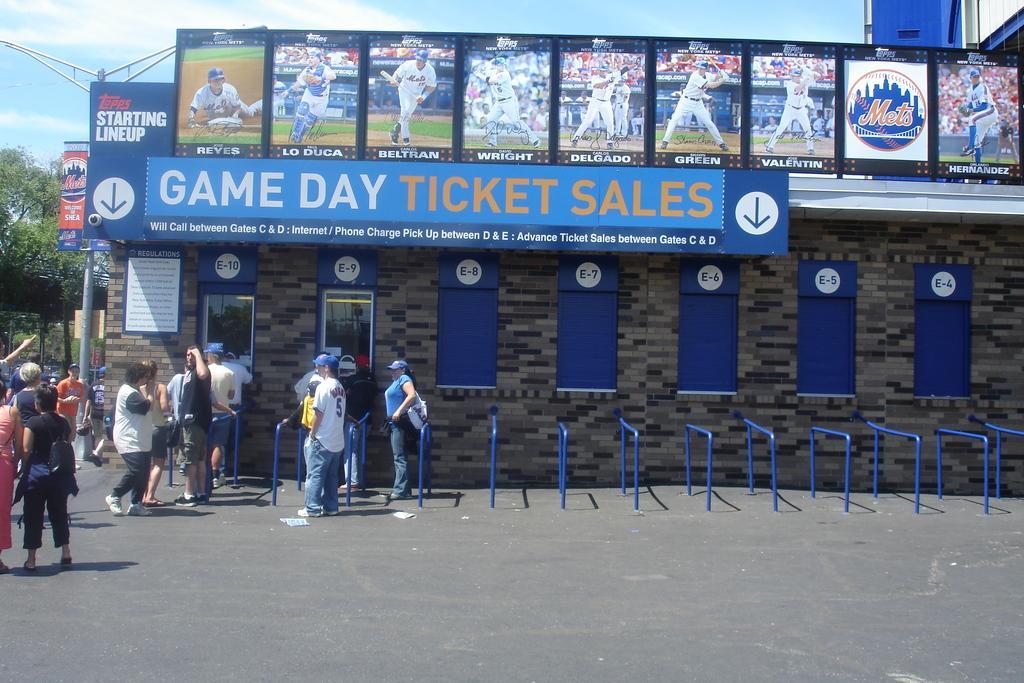Could you give a brief overview of what you see in this image? In this image I can see number of persons standing on the road and few blue colored metal rods. In the background I can see a building, few boards attached to the building, a metal pole, few trees and the sky. 